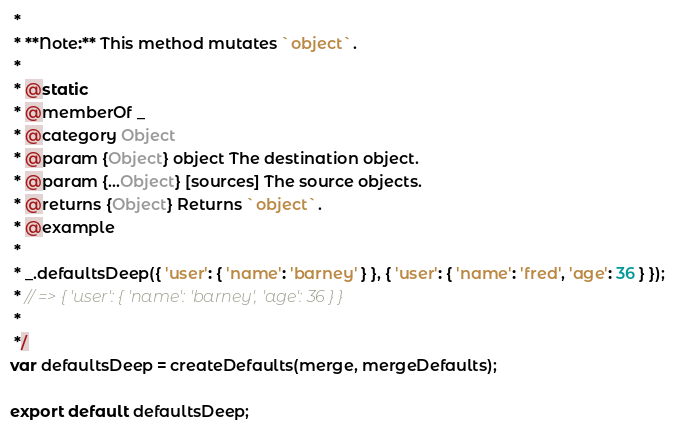Convert code to text. <code><loc_0><loc_0><loc_500><loc_500><_JavaScript_> *
 * **Note:** This method mutates `object`.
 *
 * @static
 * @memberOf _
 * @category Object
 * @param {Object} object The destination object.
 * @param {...Object} [sources] The source objects.
 * @returns {Object} Returns `object`.
 * @example
 *
 * _.defaultsDeep({ 'user': { 'name': 'barney' } }, { 'user': { 'name': 'fred', 'age': 36 } });
 * // => { 'user': { 'name': 'barney', 'age': 36 } }
 *
 */
var defaultsDeep = createDefaults(merge, mergeDefaults);

export default defaultsDeep;</code> 